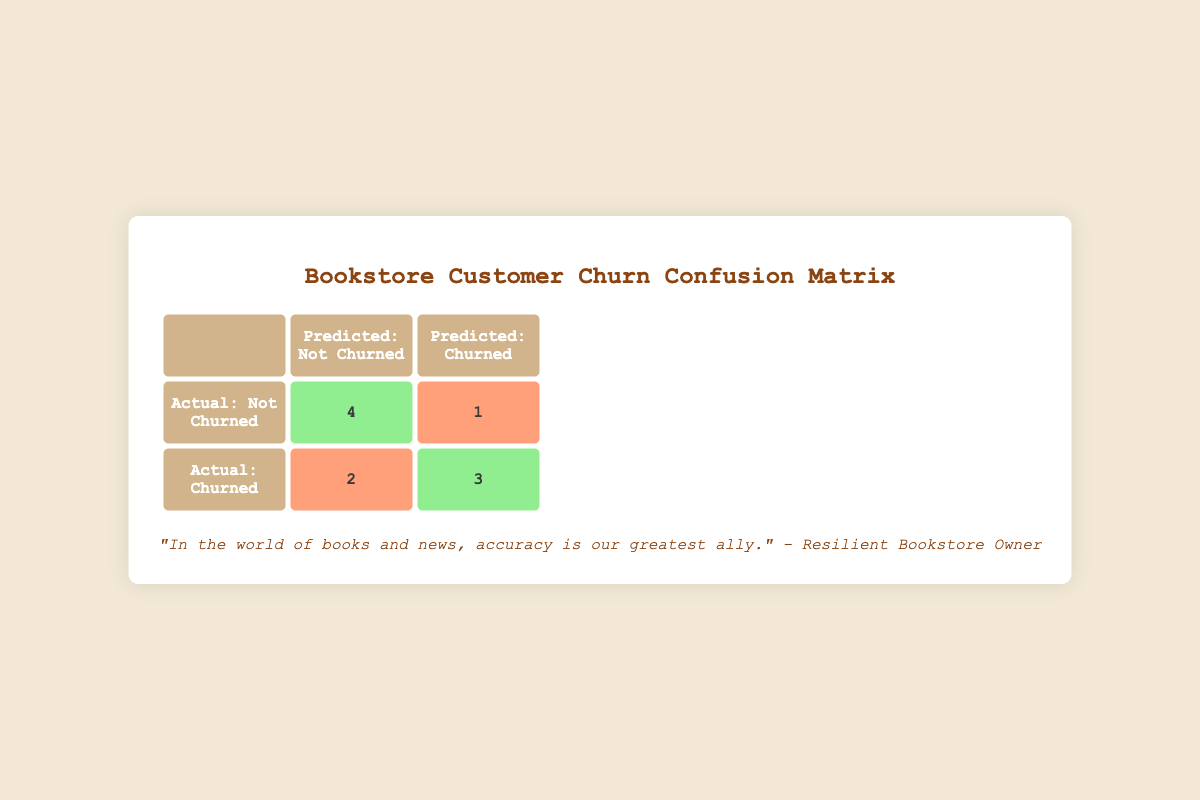What are the true positives in the confusion matrix? The true positives are represented by the actual churned customers that were correctly predicted to churned. From the table, the cell under "Actual: Churned" and "Predicted: Churned" shows the number 3.
Answer: 3 How many customers were actually churned but predicted not to churn? This refers to the false negatives, which are the customers who churned but were predicted to stay. In the table, these are found under "Actual: Churned" and "Predicted: Not Churned," which shows the number 2.
Answer: 2 What is the total number of customers predicted to churn? We can find this by adding the true positives (3) and the false positives (1) from the table, which gives us 3 + 1 = 4 customers predicted to churn.
Answer: 4 Is it true that more customers were accurately identified as not churned than incorrectly identified as churned? To determine this, we look at the true negatives (4) and the false positives (1). Since 4 is greater than 1, the statement is true.
Answer: Yes What is the total number of customers that were predicted to not churn? We can find this by adding true negatives (4) and false negatives (2) from the table. Therefore, 4 + 2 = 6 customers were predicted to not churn.
Answer: 6 What percentage of customers that actually churned were correctly predicted as churned? This requires dividing the true positives (3) by the total number of actual churned customers (which is true positives + false negatives, so 3 + 2 = 5), then multiplying by 100 for the percentage. (3/5) * 100 = 60%.
Answer: 60% How many total customers are represented in the confusion matrix? Adding all values in the matrix gives us the total number of customers. This is 4 (true negatives) + 1 (false positive) + 2 (false negative) + 3 (true positives) = 10 customers.
Answer: 10 What is the ratio of false positives to true negatives in the confusion matrix? The ratio can be calculated by taking the number of false positives (1) and comparing it to the number of true negatives (4). Thus, the ratio is 1:4.
Answer: 1:4 